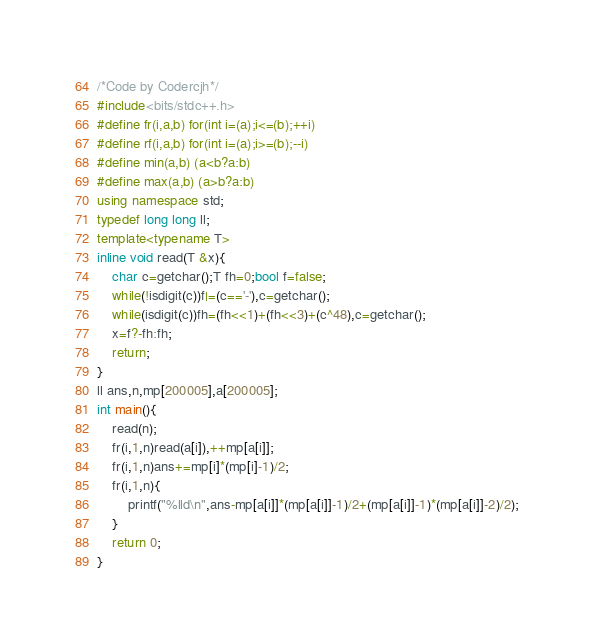<code> <loc_0><loc_0><loc_500><loc_500><_C++_>/*Code by Codercjh*/
#include<bits/stdc++.h>
#define fr(i,a,b) for(int i=(a);i<=(b);++i)
#define rf(i,a,b) for(int i=(a);i>=(b);--i)
#define min(a,b) (a<b?a:b)
#define max(a,b) (a>b?a:b)
using namespace std;
typedef long long ll;
template<typename T>
inline void read(T &x){
	char c=getchar();T fh=0;bool f=false;
	while(!isdigit(c))f|=(c=='-'),c=getchar();
	while(isdigit(c))fh=(fh<<1)+(fh<<3)+(c^48),c=getchar();
	x=f?-fh:fh;
	return;
}
ll ans,n,mp[200005],a[200005];
int main(){
    read(n);
    fr(i,1,n)read(a[i]),++mp[a[i]];
    fr(i,1,n)ans+=mp[i]*(mp[i]-1)/2;
    fr(i,1,n){
    	printf("%lld\n",ans-mp[a[i]]*(mp[a[i]]-1)/2+(mp[a[i]]-1)*(mp[a[i]]-2)/2);
	}
	return 0;
}
</code> 